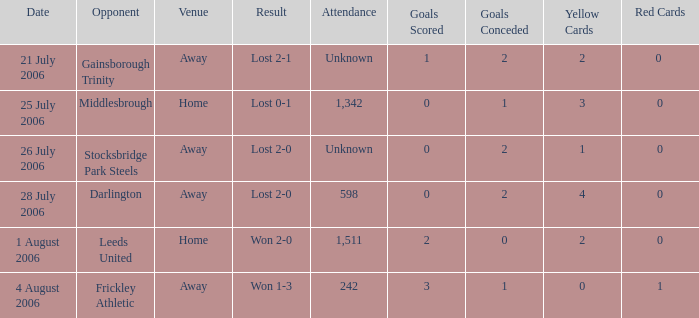Which opponent has unknown attendance, and lost 2-0? Stocksbridge Park Steels. 